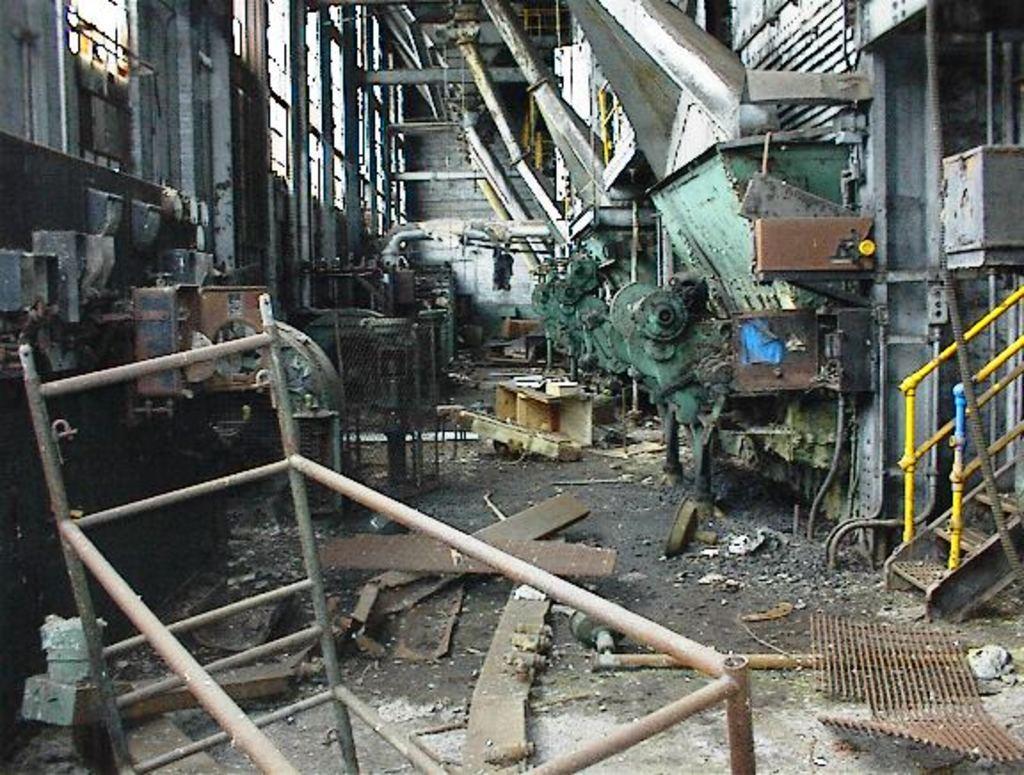Could you give a brief overview of what you see in this image? In the image we can see there is a mechanical factory where mechanical equipments are there and the area is very untidy as we can see there are items which are thrown on the ground like iron mesh, rod and wooden plates. 